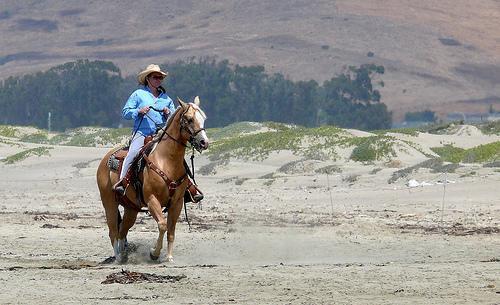How many horses are there?
Give a very brief answer. 1. 